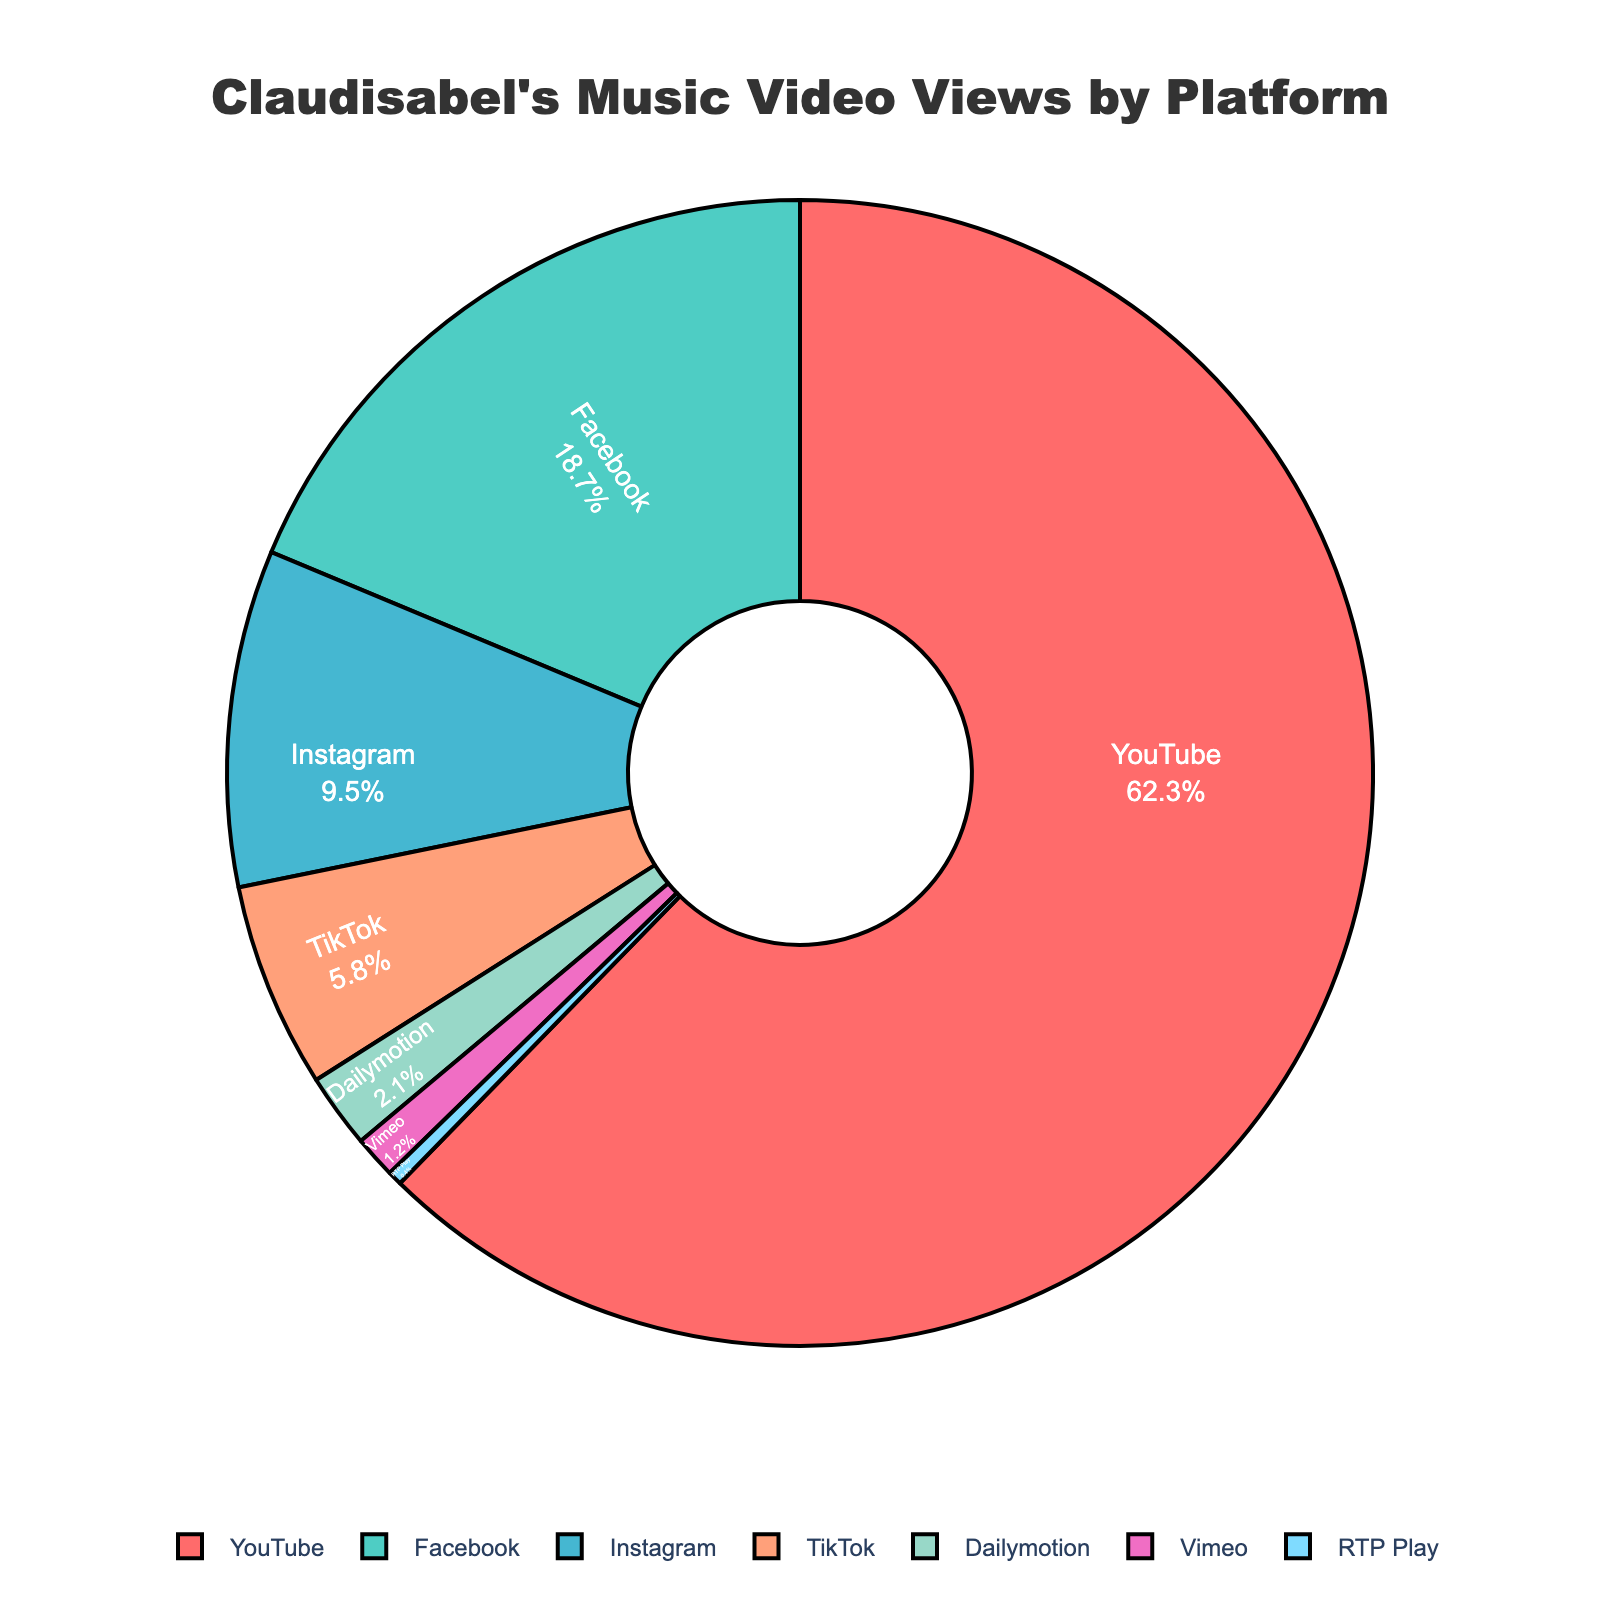What percentage of Claudisabel's music video views come from platforms other than YouTube? To find the percentage of views that come from platforms other than YouTube, subtract YouTube's percentage from 100%. It’s 100% - 62.3% = 37.7%.
Answer: 37.7% Which platform has the second highest percentage of music video views for Claudisabel? By looking at the data, after YouTube, Facebook has the next highest percentage of views at 18.7%.
Answer: Facebook What is the total percentage of views from Instagram, TikTok, and Vimeo combined? To find the combined percentage, add the percentages of Instagram (9.5%), TikTok (5.8%), and Vimeo (1.2%). So, 9.5% + 5.8% + 1.2% = 16.5%.
Answer: 16.5% Is the percentage of views from Facebook more than double the percentage from Instagram? Compare Facebook's 18.7% to double Instagram's 9.5% (which is 19%). Since 18.7% is slightly less than 19%, the answer is no.
Answer: No Which platforms have less than 5% of Claudisabel's music video views? According to the data, TikTok (5.8%), Dailymotion (2.1%), Vimeo (1.2%), and RTP Play (0.4%) have less than 5% of views.
Answer: Dailymotion, Vimeo, RTP Play What is the percentage difference between the highest and lowest view platforms? Find the difference between the highest percentage (YouTube at 62.3%) and the lowest percentage (RTP Play at 0.4%). It’s 62.3% - 0.4% = 61.9%.
Answer: 61.9% Which platform has a slice colored in pink? Colors are associated with slices in the pie chart, but without the image, assume the first color (typically pink in defaults) as the highest percentage. YouTube has the highest at 62.3%.
Answer: YouTube Do YouTube and Facebook together account for more than three-quarters of the views? Add YouTube's percentage (62.3%) to Facebook's percentage (18.7%). Their total is 62.3% + 18.7% = 81%, which is more than 75%.
Answer: Yes 